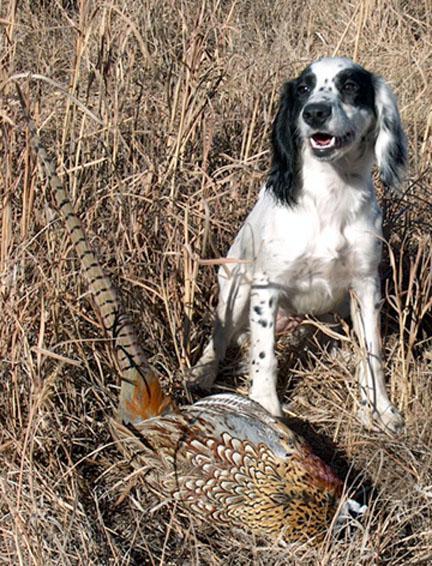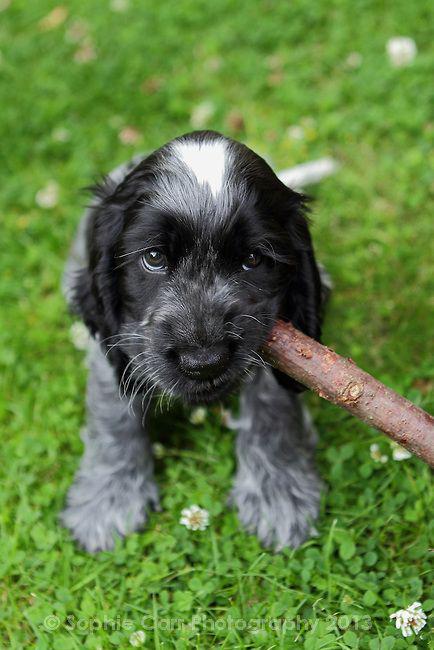The first image is the image on the left, the second image is the image on the right. Evaluate the accuracy of this statement regarding the images: "One of the dogs is carrying something in its mouth.". Is it true? Answer yes or no. Yes. The first image is the image on the left, the second image is the image on the right. Given the left and right images, does the statement "The dog in the image on the right is carrying something in it's mouth." hold true? Answer yes or no. Yes. 